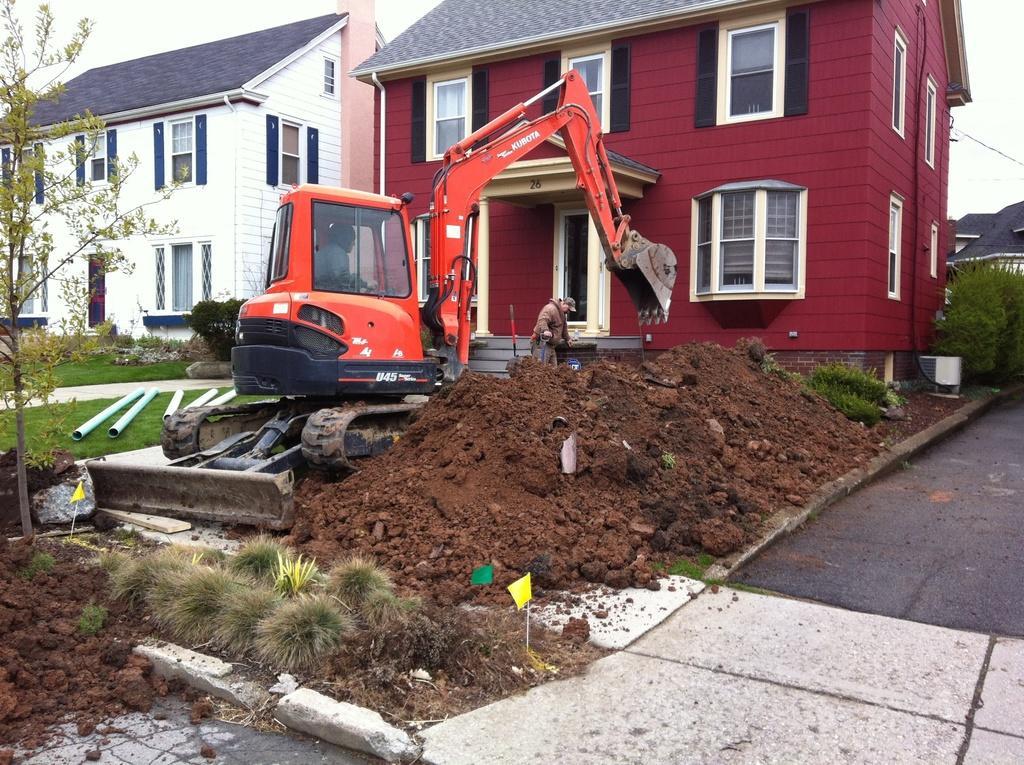How would you summarize this image in a sentence or two? In this picture we can see a person standing. There is some soil and grass on the ground. We can see few pipes on the grass. There is a crane and a person is visible in it. There are few buildings, wires and plants is visible in the background. 